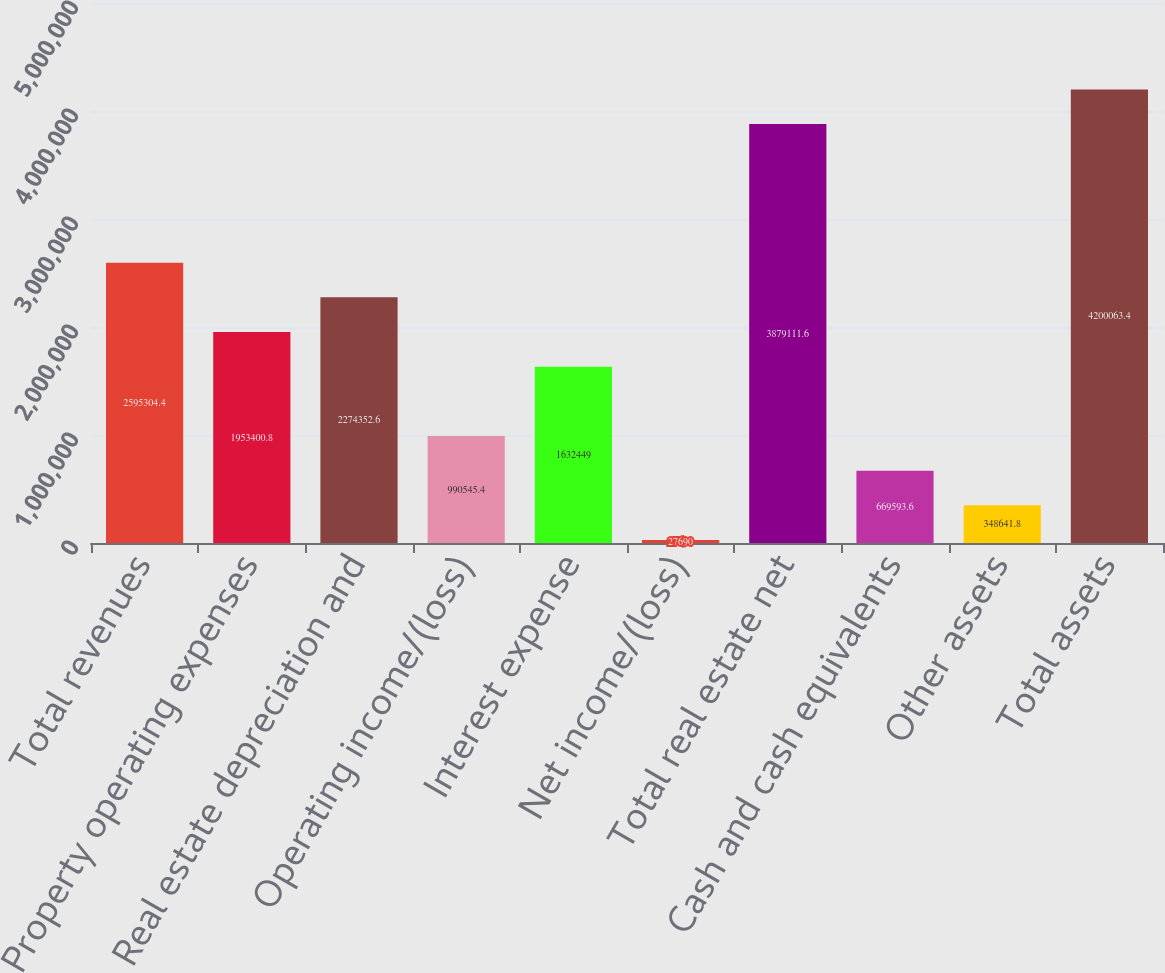<chart> <loc_0><loc_0><loc_500><loc_500><bar_chart><fcel>Total revenues<fcel>Property operating expenses<fcel>Real estate depreciation and<fcel>Operating income/(loss)<fcel>Interest expense<fcel>Net income/(loss)<fcel>Total real estate net<fcel>Cash and cash equivalents<fcel>Other assets<fcel>Total assets<nl><fcel>2.5953e+06<fcel>1.9534e+06<fcel>2.27435e+06<fcel>990545<fcel>1.63245e+06<fcel>27690<fcel>3.87911e+06<fcel>669594<fcel>348642<fcel>4.20006e+06<nl></chart> 